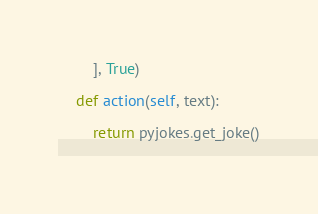Convert code to text. <code><loc_0><loc_0><loc_500><loc_500><_Python_>        ], True)
        
    def action(self, text):
        
        return pyjokes.get_joke()
        </code> 